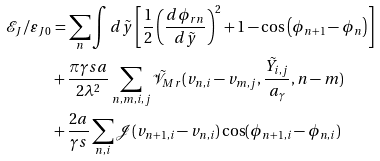Convert formula to latex. <formula><loc_0><loc_0><loc_500><loc_500>\mathcal { E } _ { J } / \varepsilon _ { J 0 } & = \sum _ { n } \int d \tilde { y } \left [ \frac { 1 } { 2 } \left ( \frac { d \phi _ { r n } } { d \tilde { y } } \right ) ^ { 2 } + 1 - \cos \left ( \phi _ { n + 1 } - \phi _ { n } \right ) \right ] \\ & + \frac { \pi \gamma s a } { 2 \lambda ^ { 2 } } \sum _ { n , m , i , j } \mathcal { \tilde { V } } _ { M r } ( v _ { n , i } - v _ { m , j } , \frac { \tilde { Y } _ { i , j } } { a _ { \gamma } } , n - m ) \\ & + \frac { 2 a } { \gamma s } \sum _ { n , i } \mathcal { J } ( v _ { n + 1 , i } - v _ { n , i } ) \cos ( \phi _ { n + 1 , i } - \phi _ { n , i } )</formula> 